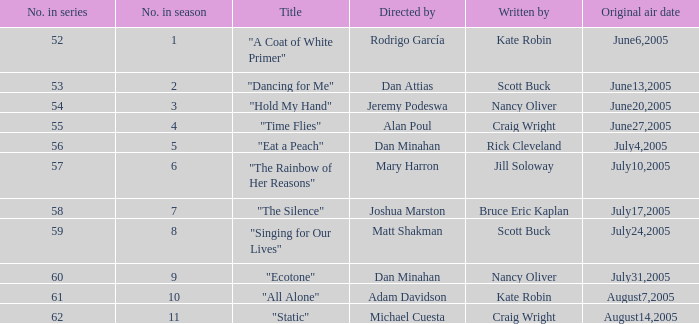Can you give me this table as a dict? {'header': ['No. in series', 'No. in season', 'Title', 'Directed by', 'Written by', 'Original air date'], 'rows': [['52', '1', '"A Coat of White Primer"', 'Rodrigo García', 'Kate Robin', 'June6,2005'], ['53', '2', '"Dancing for Me"', 'Dan Attias', 'Scott Buck', 'June13,2005'], ['54', '3', '"Hold My Hand"', 'Jeremy Podeswa', 'Nancy Oliver', 'June20,2005'], ['55', '4', '"Time Flies"', 'Alan Poul', 'Craig Wright', 'June27,2005'], ['56', '5', '"Eat a Peach"', 'Dan Minahan', 'Rick Cleveland', 'July4,2005'], ['57', '6', '"The Rainbow of Her Reasons"', 'Mary Harron', 'Jill Soloway', 'July10,2005'], ['58', '7', '"The Silence"', 'Joshua Marston', 'Bruce Eric Kaplan', 'July17,2005'], ['59', '8', '"Singing for Our Lives"', 'Matt Shakman', 'Scott Buck', 'July24,2005'], ['60', '9', '"Ecotone"', 'Dan Minahan', 'Nancy Oliver', 'July31,2005'], ['61', '10', '"All Alone"', 'Adam Davidson', 'Kate Robin', 'August7,2005'], ['62', '11', '"Static"', 'Michael Cuesta', 'Craig Wright', 'August14,2005']]} What s the episode number in the season that was written by Nancy Oliver? 9.0. 